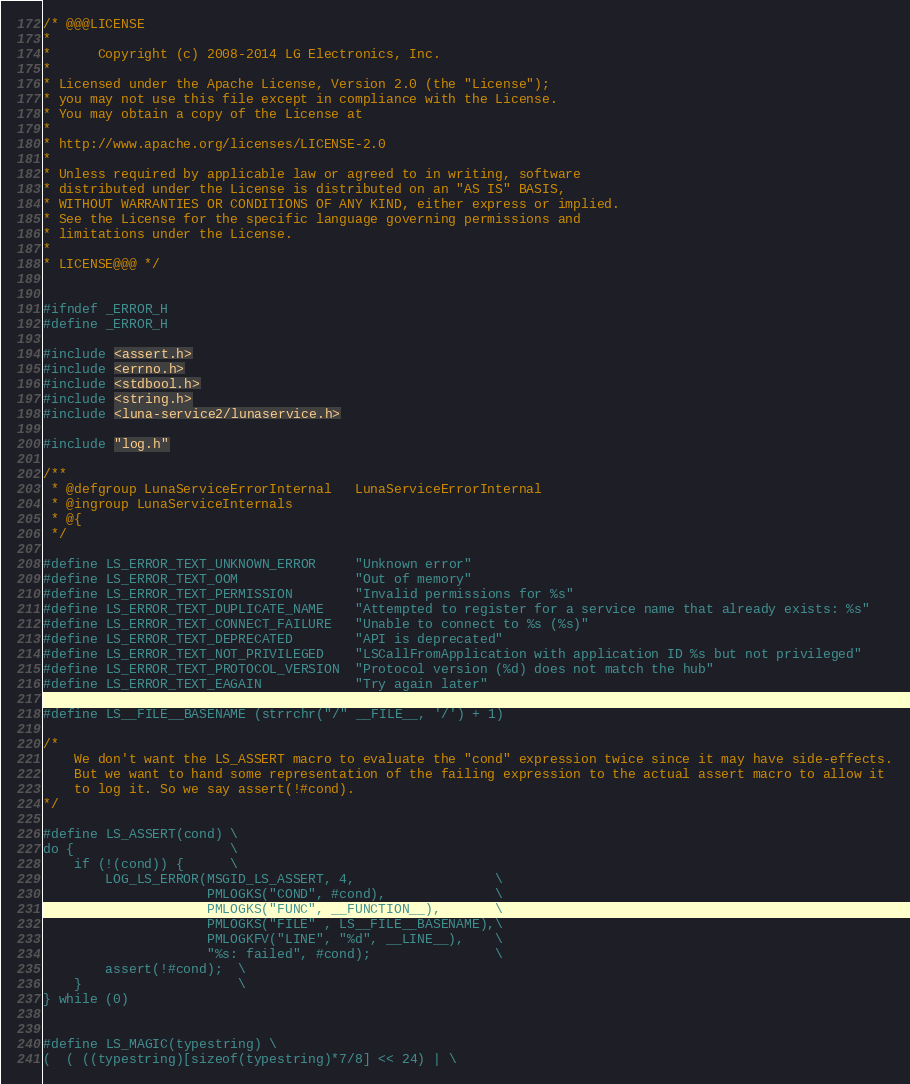Convert code to text. <code><loc_0><loc_0><loc_500><loc_500><_C_>/* @@@LICENSE
*
*      Copyright (c) 2008-2014 LG Electronics, Inc.
*
* Licensed under the Apache License, Version 2.0 (the "License");
* you may not use this file except in compliance with the License.
* You may obtain a copy of the License at
*
* http://www.apache.org/licenses/LICENSE-2.0
*
* Unless required by applicable law or agreed to in writing, software
* distributed under the License is distributed on an "AS IS" BASIS,
* WITHOUT WARRANTIES OR CONDITIONS OF ANY KIND, either express or implied.
* See the License for the specific language governing permissions and
* limitations under the License.
*
* LICENSE@@@ */


#ifndef _ERROR_H
#define _ERROR_H

#include <assert.h>
#include <errno.h>
#include <stdbool.h>
#include <string.h>
#include <luna-service2/lunaservice.h>

#include "log.h"

/**
 * @defgroup LunaServiceErrorInternal   LunaServiceErrorInternal
 * @ingroup LunaServiceInternals
 * @{
 */

#define LS_ERROR_TEXT_UNKNOWN_ERROR     "Unknown error"
#define LS_ERROR_TEXT_OOM               "Out of memory"
#define LS_ERROR_TEXT_PERMISSION        "Invalid permissions for %s"
#define LS_ERROR_TEXT_DUPLICATE_NAME    "Attempted to register for a service name that already exists: %s"
#define LS_ERROR_TEXT_CONNECT_FAILURE   "Unable to connect to %s (%s)"
#define LS_ERROR_TEXT_DEPRECATED        "API is deprecated"
#define LS_ERROR_TEXT_NOT_PRIVILEGED    "LSCallFromApplication with application ID %s but not privileged"
#define LS_ERROR_TEXT_PROTOCOL_VERSION  "Protocol version (%d) does not match the hub"
#define LS_ERROR_TEXT_EAGAIN            "Try again later"

#define LS__FILE__BASENAME (strrchr("/" __FILE__, '/') + 1)

/*
    We don't want the LS_ASSERT macro to evaluate the "cond" expression twice since it may have side-effects.
    But we want to hand some representation of the failing expression to the actual assert macro to allow it
    to log it. So we say assert(!#cond).
*/

#define LS_ASSERT(cond) \
do {                    \
    if (!(cond)) {      \
        LOG_LS_ERROR(MSGID_LS_ASSERT, 4,                  \
                     PMLOGKS("COND", #cond),              \
                     PMLOGKS("FUNC", __FUNCTION__),       \
                     PMLOGKS("FILE" , LS__FILE__BASENAME),\
                     PMLOGKFV("LINE", "%d", __LINE__),    \
                     "%s: failed", #cond);                \
        assert(!#cond);  \
    }                    \
} while (0)


#define LS_MAGIC(typestring) \
(  ( ((typestring)[sizeof(typestring)*7/8] << 24) | \</code> 